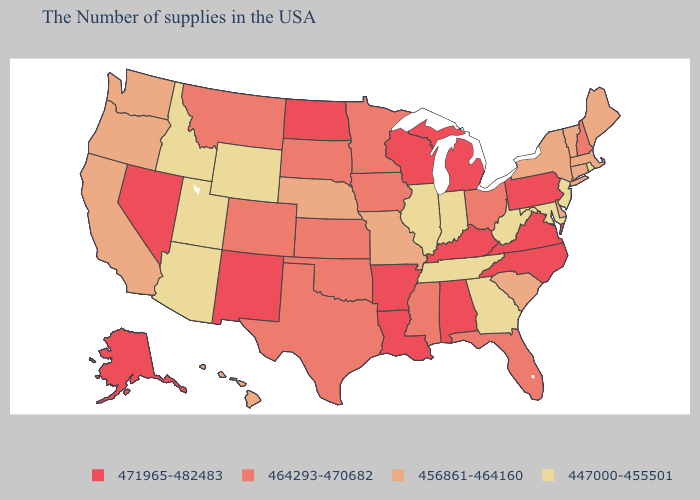Among the states that border Wisconsin , does Illinois have the highest value?
Be succinct. No. Does Michigan have the same value as Vermont?
Short answer required. No. Name the states that have a value in the range 456861-464160?
Give a very brief answer. Maine, Massachusetts, Vermont, Connecticut, New York, Delaware, South Carolina, Missouri, Nebraska, California, Washington, Oregon, Hawaii. Name the states that have a value in the range 464293-470682?
Write a very short answer. New Hampshire, Ohio, Florida, Mississippi, Minnesota, Iowa, Kansas, Oklahoma, Texas, South Dakota, Colorado, Montana. Does Louisiana have the same value as Arizona?
Quick response, please. No. Name the states that have a value in the range 464293-470682?
Give a very brief answer. New Hampshire, Ohio, Florida, Mississippi, Minnesota, Iowa, Kansas, Oklahoma, Texas, South Dakota, Colorado, Montana. What is the value of New York?
Answer briefly. 456861-464160. Among the states that border Ohio , which have the highest value?
Answer briefly. Pennsylvania, Michigan, Kentucky. Does Rhode Island have the lowest value in the Northeast?
Write a very short answer. Yes. How many symbols are there in the legend?
Give a very brief answer. 4. What is the value of North Dakota?
Keep it brief. 471965-482483. How many symbols are there in the legend?
Short answer required. 4. Name the states that have a value in the range 464293-470682?
Write a very short answer. New Hampshire, Ohio, Florida, Mississippi, Minnesota, Iowa, Kansas, Oklahoma, Texas, South Dakota, Colorado, Montana. Does the first symbol in the legend represent the smallest category?
Keep it brief. No. Name the states that have a value in the range 456861-464160?
Keep it brief. Maine, Massachusetts, Vermont, Connecticut, New York, Delaware, South Carolina, Missouri, Nebraska, California, Washington, Oregon, Hawaii. 